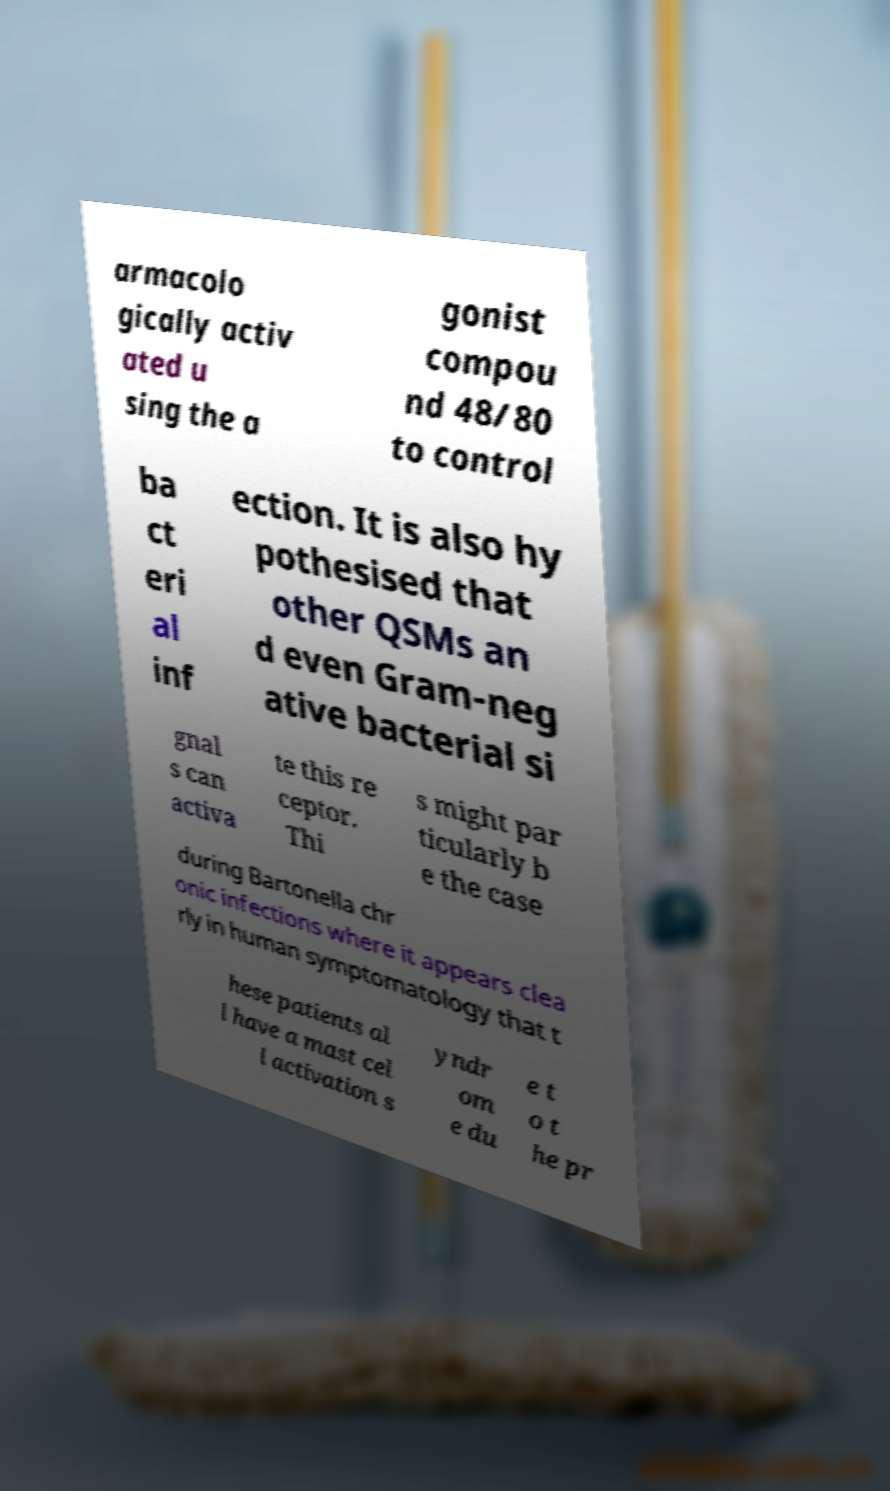What messages or text are displayed in this image? I need them in a readable, typed format. armacolo gically activ ated u sing the a gonist compou nd 48/80 to control ba ct eri al inf ection. It is also hy pothesised that other QSMs an d even Gram-neg ative bacterial si gnal s can activa te this re ceptor. Thi s might par ticularly b e the case during Bartonella chr onic infections where it appears clea rly in human symptomatology that t hese patients al l have a mast cel l activation s yndr om e du e t o t he pr 